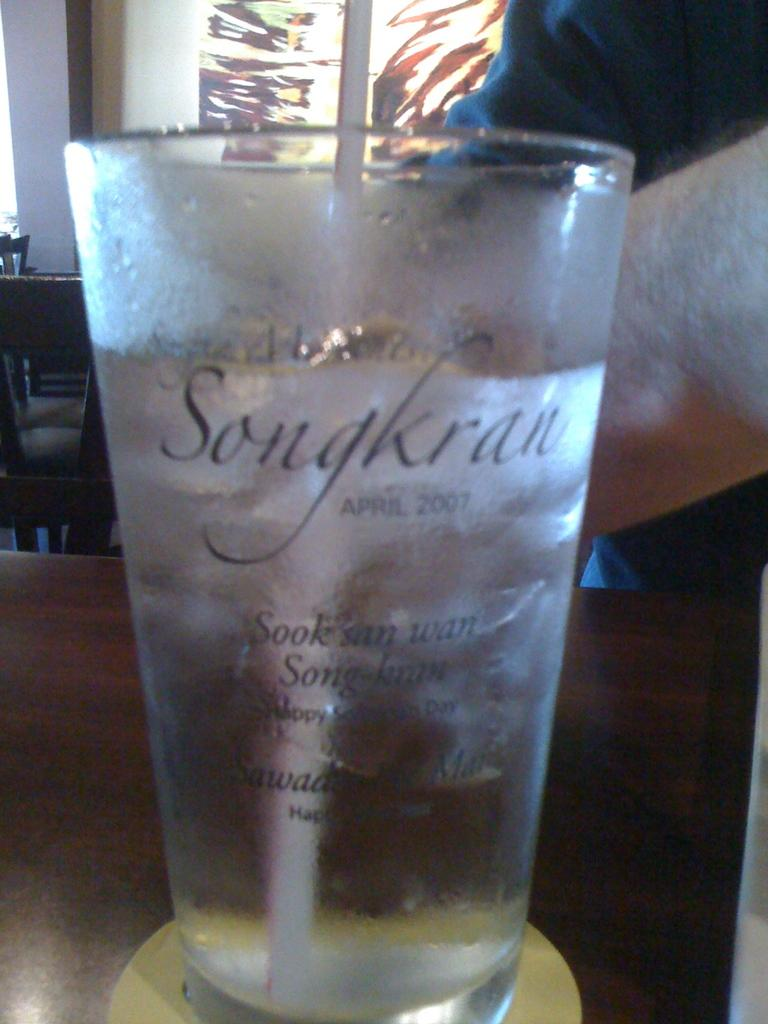<image>
Present a compact description of the photo's key features. A glass with a straw in it and the word Songkran on it 